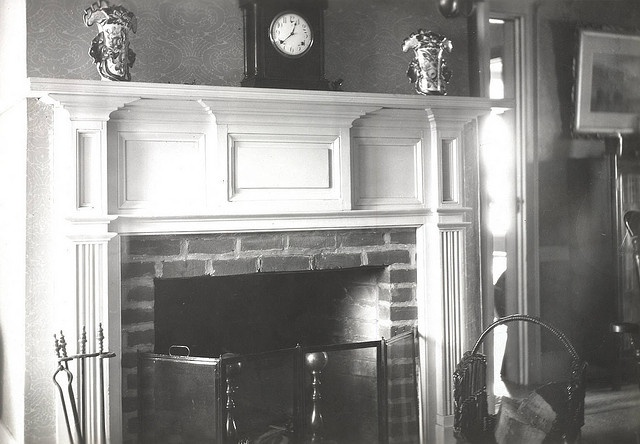Describe the objects in this image and their specific colors. I can see vase in lightgray, gray, darkgray, and black tones, vase in lightgray, gray, white, darkgray, and black tones, and clock in lightgray, darkgray, gray, and black tones in this image. 